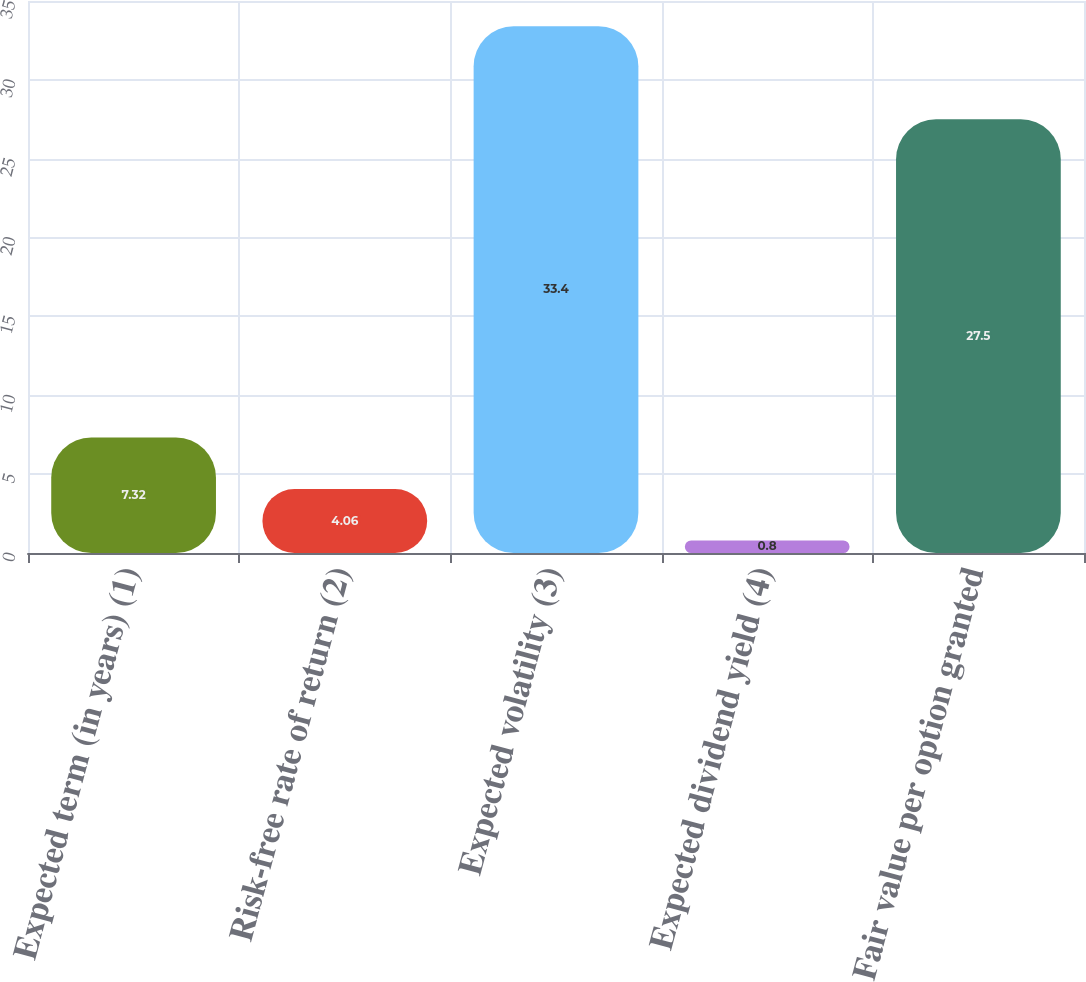Convert chart to OTSL. <chart><loc_0><loc_0><loc_500><loc_500><bar_chart><fcel>Expected term (in years) (1)<fcel>Risk-free rate of return (2)<fcel>Expected volatility (3)<fcel>Expected dividend yield (4)<fcel>Fair value per option granted<nl><fcel>7.32<fcel>4.06<fcel>33.4<fcel>0.8<fcel>27.5<nl></chart> 